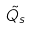Convert formula to latex. <formula><loc_0><loc_0><loc_500><loc_500>\tilde { Q _ { s } }</formula> 